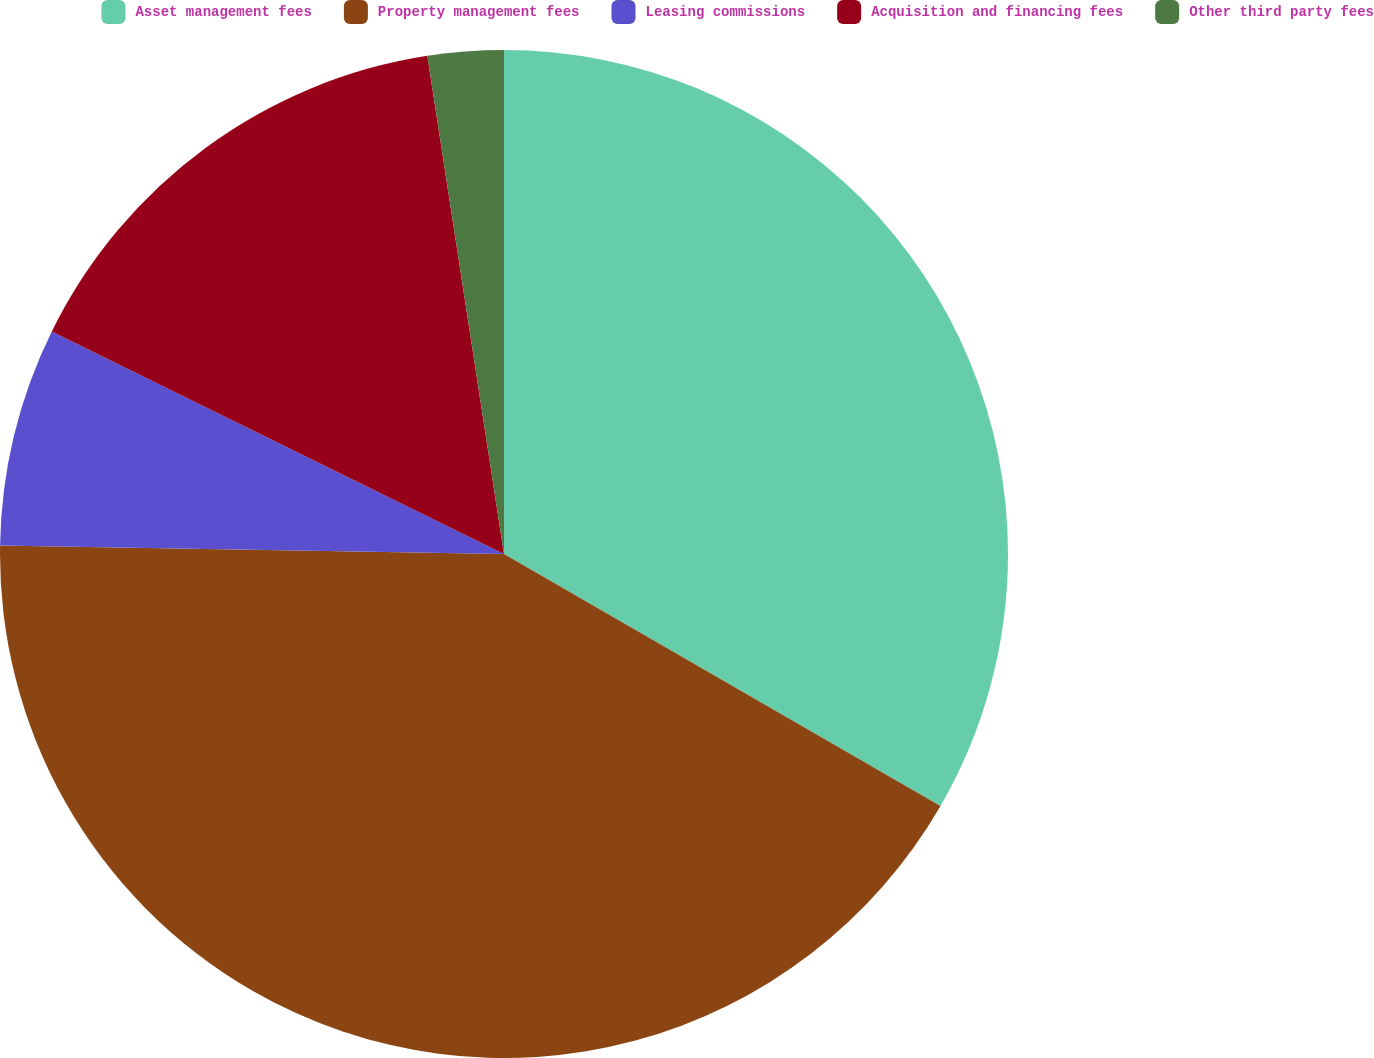<chart> <loc_0><loc_0><loc_500><loc_500><pie_chart><fcel>Asset management fees<fcel>Property management fees<fcel>Leasing commissions<fcel>Acquisition and financing fees<fcel>Other third party fees<nl><fcel>33.33%<fcel>41.93%<fcel>7.01%<fcel>15.29%<fcel>2.43%<nl></chart> 